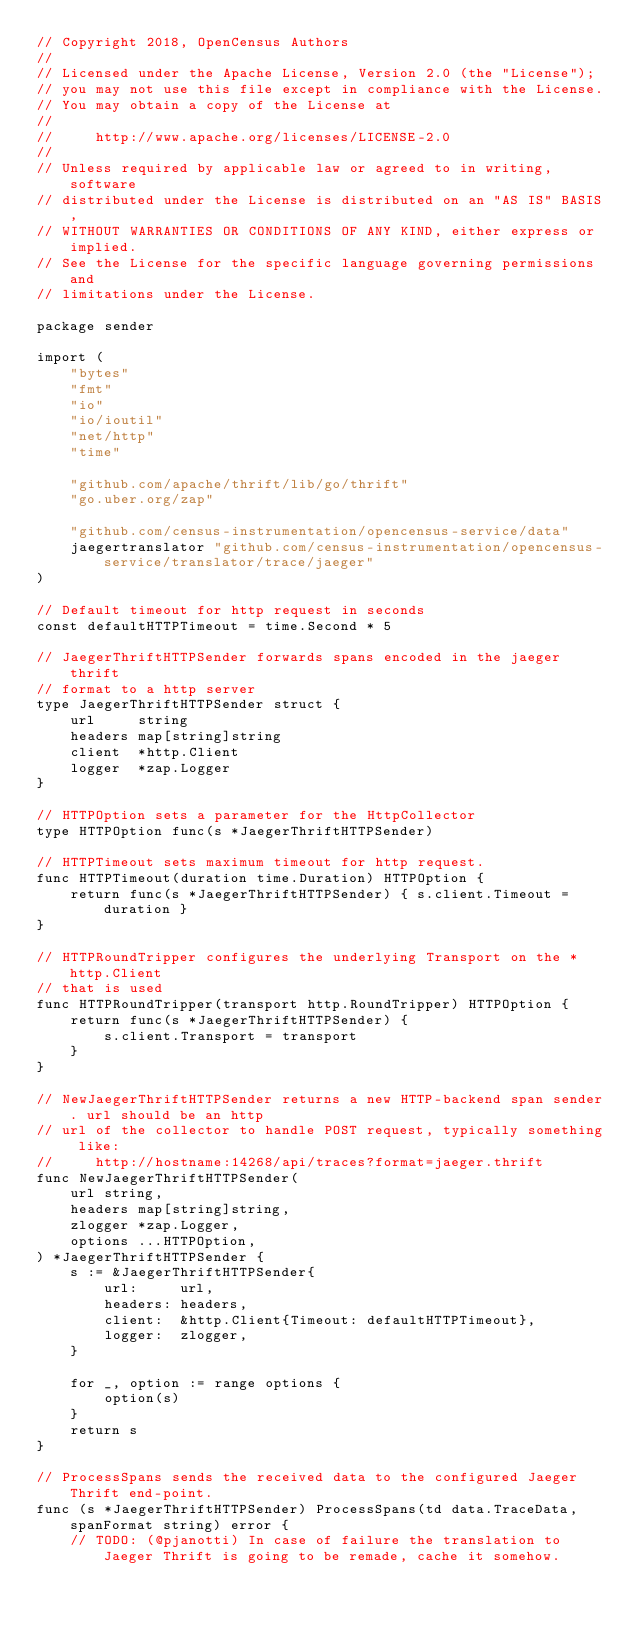Convert code to text. <code><loc_0><loc_0><loc_500><loc_500><_Go_>// Copyright 2018, OpenCensus Authors
//
// Licensed under the Apache License, Version 2.0 (the "License");
// you may not use this file except in compliance with the License.
// You may obtain a copy of the License at
//
//     http://www.apache.org/licenses/LICENSE-2.0
//
// Unless required by applicable law or agreed to in writing, software
// distributed under the License is distributed on an "AS IS" BASIS,
// WITHOUT WARRANTIES OR CONDITIONS OF ANY KIND, either express or implied.
// See the License for the specific language governing permissions and
// limitations under the License.

package sender

import (
	"bytes"
	"fmt"
	"io"
	"io/ioutil"
	"net/http"
	"time"

	"github.com/apache/thrift/lib/go/thrift"
	"go.uber.org/zap"

	"github.com/census-instrumentation/opencensus-service/data"
	jaegertranslator "github.com/census-instrumentation/opencensus-service/translator/trace/jaeger"
)

// Default timeout for http request in seconds
const defaultHTTPTimeout = time.Second * 5

// JaegerThriftHTTPSender forwards spans encoded in the jaeger thrift
// format to a http server
type JaegerThriftHTTPSender struct {
	url     string
	headers map[string]string
	client  *http.Client
	logger  *zap.Logger
}

// HTTPOption sets a parameter for the HttpCollector
type HTTPOption func(s *JaegerThriftHTTPSender)

// HTTPTimeout sets maximum timeout for http request.
func HTTPTimeout(duration time.Duration) HTTPOption {
	return func(s *JaegerThriftHTTPSender) { s.client.Timeout = duration }
}

// HTTPRoundTripper configures the underlying Transport on the *http.Client
// that is used
func HTTPRoundTripper(transport http.RoundTripper) HTTPOption {
	return func(s *JaegerThriftHTTPSender) {
		s.client.Transport = transport
	}
}

// NewJaegerThriftHTTPSender returns a new HTTP-backend span sender. url should be an http
// url of the collector to handle POST request, typically something like:
//     http://hostname:14268/api/traces?format=jaeger.thrift
func NewJaegerThriftHTTPSender(
	url string,
	headers map[string]string,
	zlogger *zap.Logger,
	options ...HTTPOption,
) *JaegerThriftHTTPSender {
	s := &JaegerThriftHTTPSender{
		url:     url,
		headers: headers,
		client:  &http.Client{Timeout: defaultHTTPTimeout},
		logger:  zlogger,
	}

	for _, option := range options {
		option(s)
	}
	return s
}

// ProcessSpans sends the received data to the configured Jaeger Thrift end-point.
func (s *JaegerThriftHTTPSender) ProcessSpans(td data.TraceData, spanFormat string) error {
	// TODO: (@pjanotti) In case of failure the translation to Jaeger Thrift is going to be remade, cache it somehow.</code> 